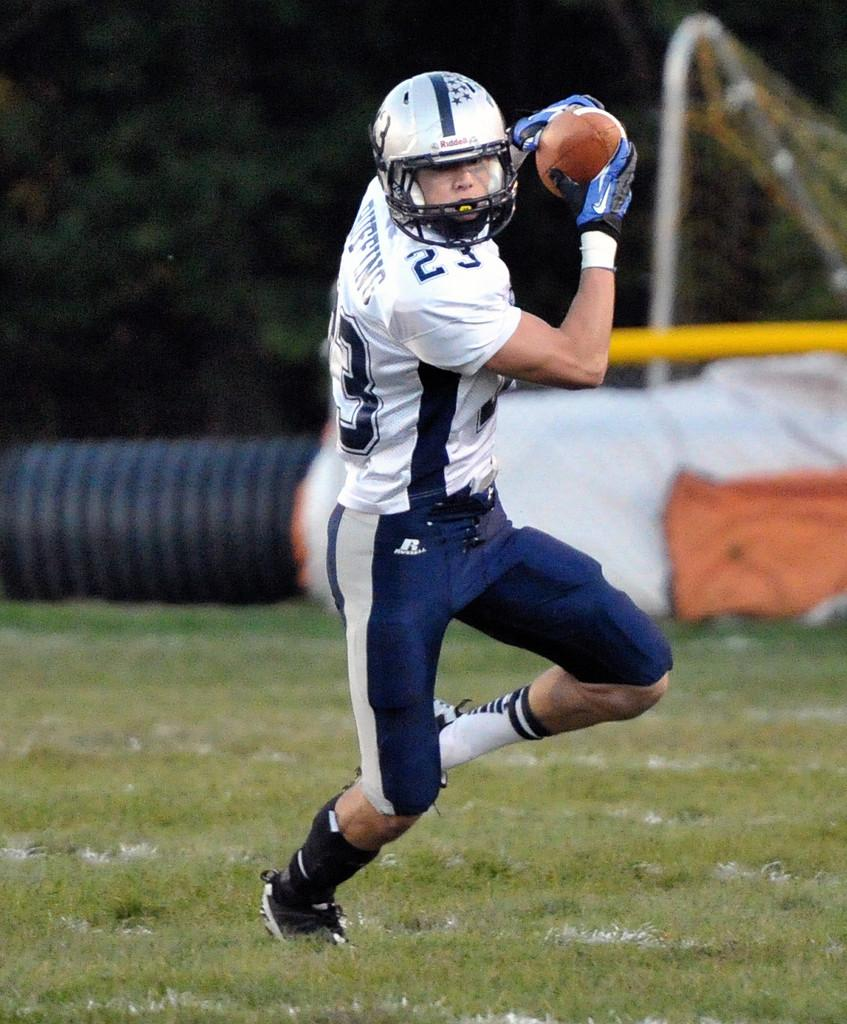What can be seen in the image? There is a person in the image. Can you describe the person's attire? The person is wearing clothes, a helmet, gloves, and shoes. What is the person holding in their hands? The person is holding a ball in their hands. What type of surface is visible in the image? There is grass visible in the image. How would you describe the background of the image? The background of the image is blurred. Are there any flowers visible on the table in the image? There is no table present in the image, and therefore no flowers can be seen on it. 